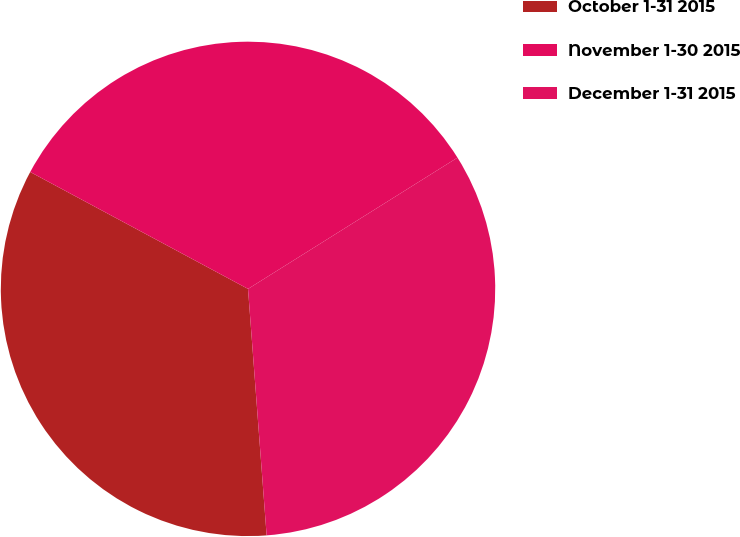<chart> <loc_0><loc_0><loc_500><loc_500><pie_chart><fcel>October 1-31 2015<fcel>November 1-30 2015<fcel>December 1-31 2015<nl><fcel>34.04%<fcel>33.25%<fcel>32.71%<nl></chart> 